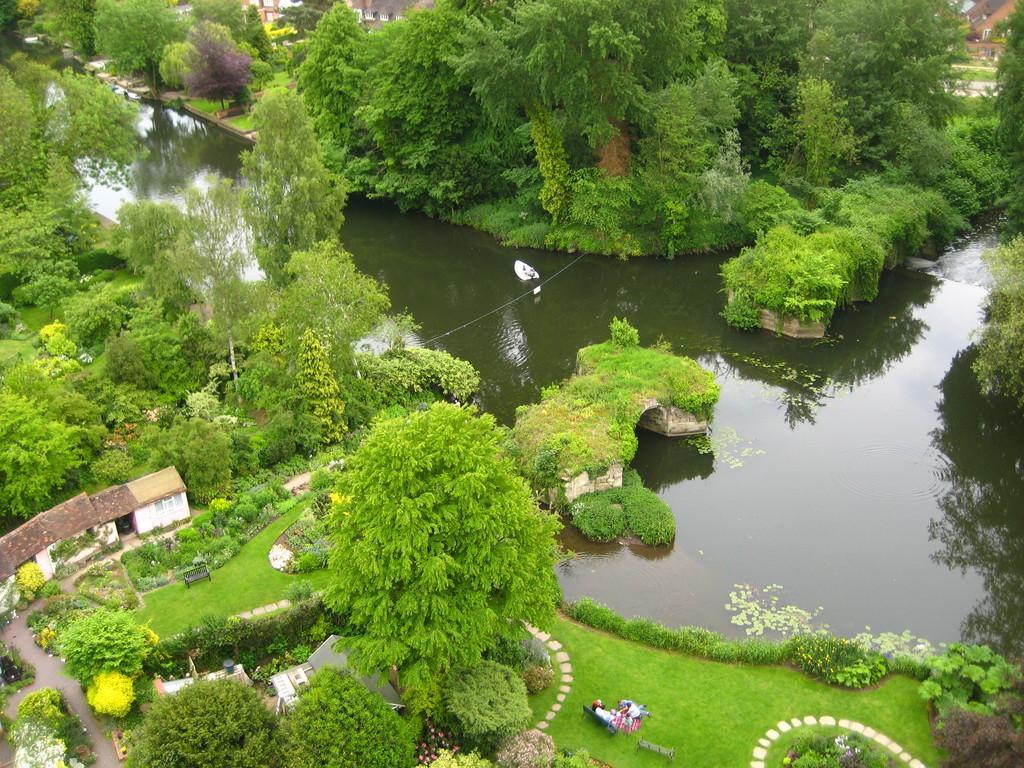Could you give a brief overview of what you see in this image? In this image we can see water, grass, plants, houses, road, trees, benches, and people. 